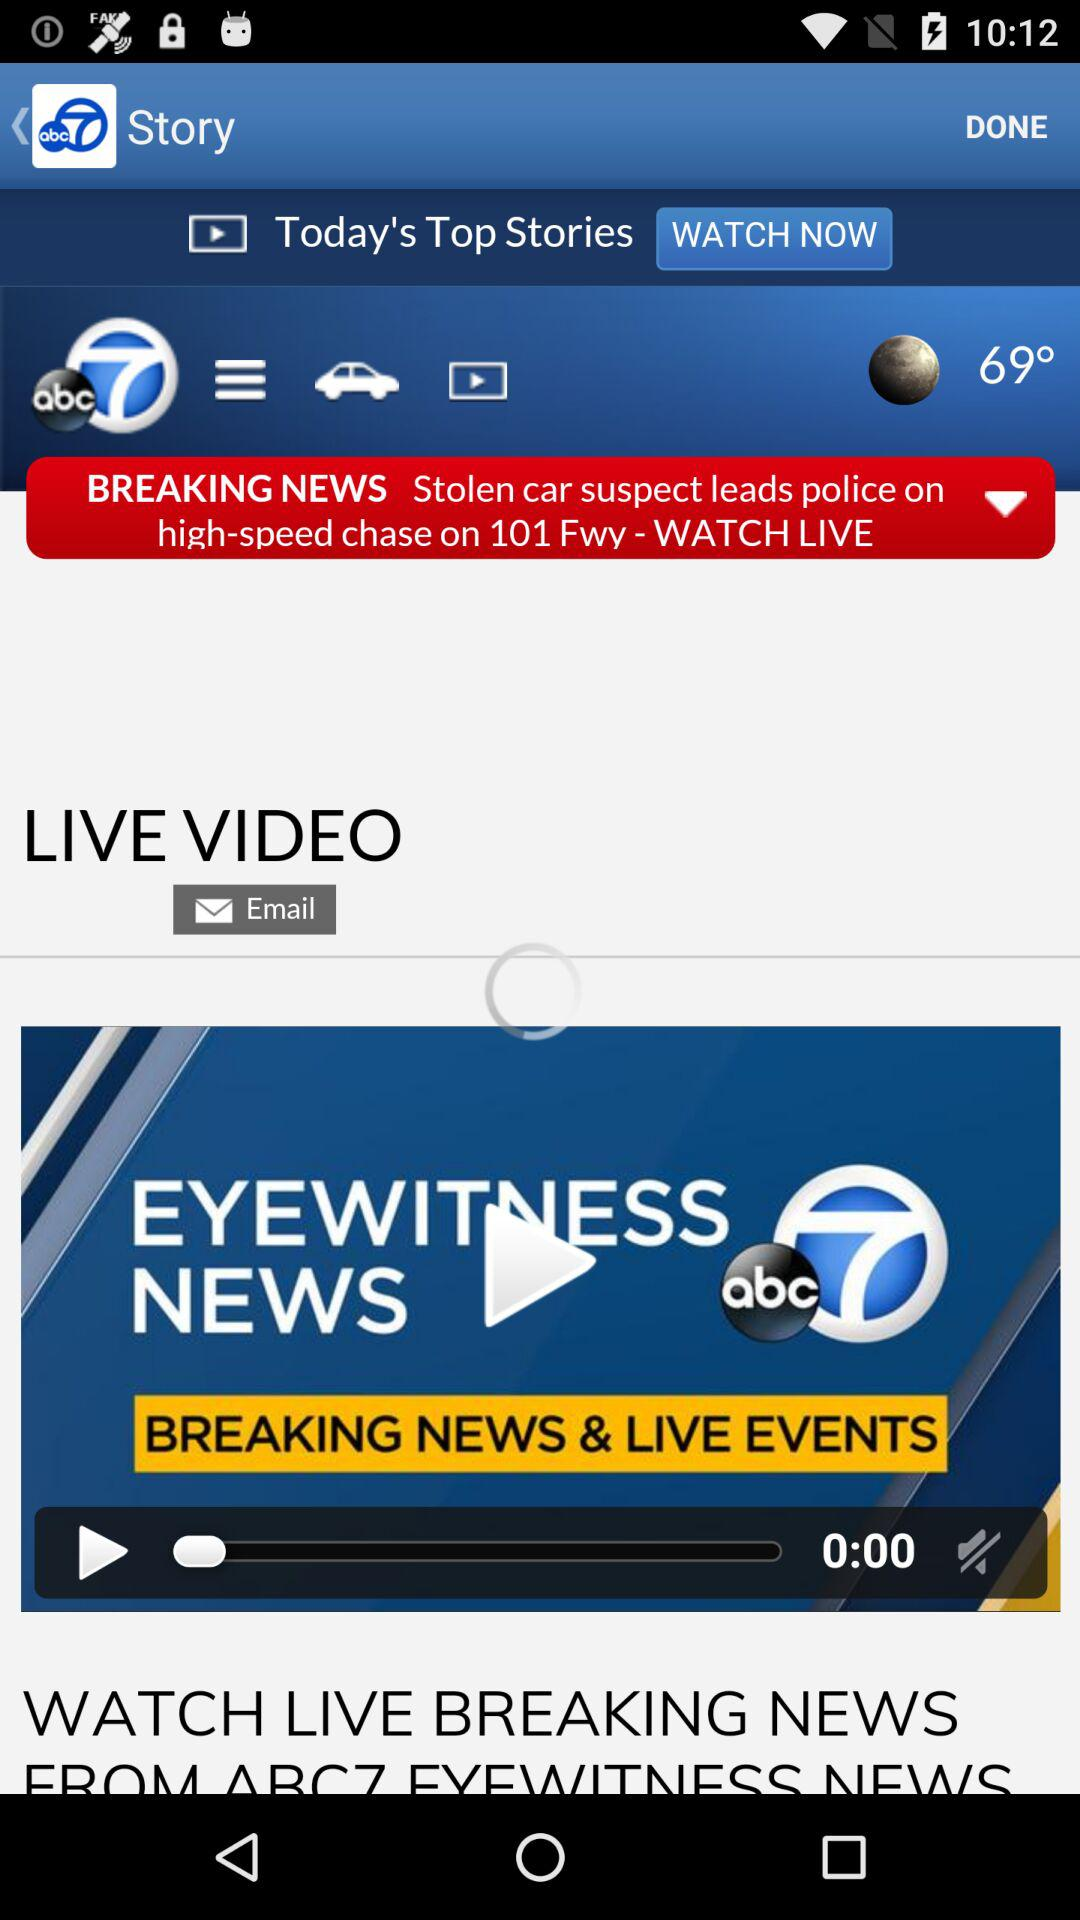Who published the video?
When the provided information is insufficient, respond with <no answer>. <no answer> 